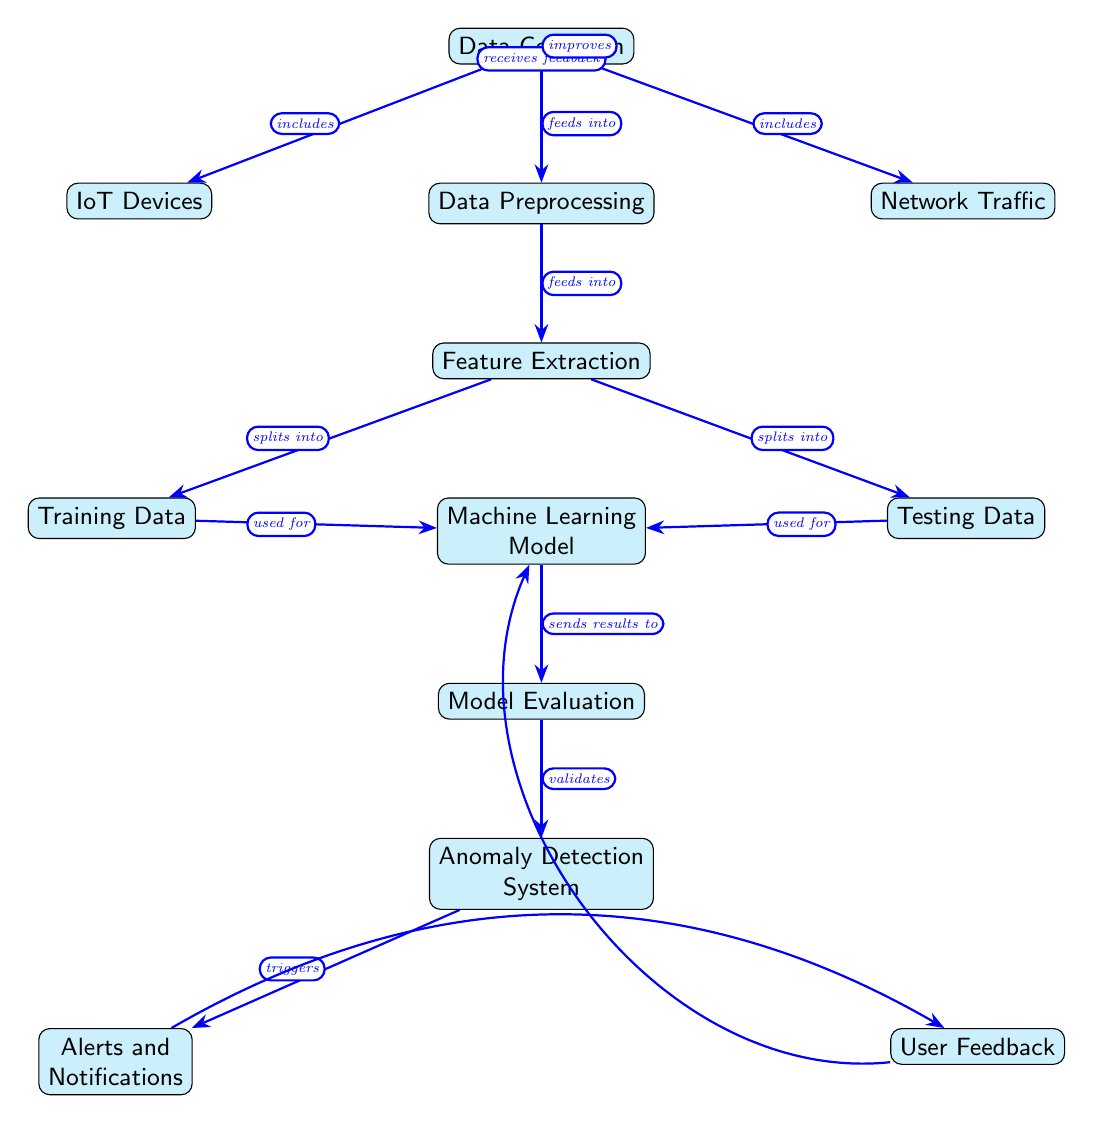What are the two types of data included in Data Collection? The diagram shows two nodes connected to Data Collection: IoT Devices and Network Traffic. These represent the types of data collected for anomaly detection.
Answer: IoT Devices, Network Traffic How many nodes are there in total? The diagram includes 12 distinct nodes, each representing a step or component in the anomaly detection process.
Answer: 12 What is the purpose of the Anomaly Detection System? Anomaly Detection System is the end goal of the process, validated by the preceding model evaluation, and it triggers alerts and notifications upon detecting anomalies.
Answer: Triggers alerts and notifications Which node follows Data Preprocessing? Data Preprocessing feeds into Feature Extraction, making it the immediate successor in the flow of the diagram.
Answer: Feature Extraction What types of data are produced from Feature Extraction? Feature Extraction splits into Training Data and Testing Data, which are both used to develop the machine learning model.
Answer: Training Data, Testing Data What does Model Evaluation send results to? The flow indicates that Model Evaluation sends results to the Anomaly Detection System, which relies on these evaluations to function effectively.
Answer: Anomaly Detection System What role does User Feedback play in the diagram? User Feedback receives input from Alerts and Notifications and is used to improve the Machine Learning Model, indicating it contributes to enhancing the system's performance over time.
Answer: Improves How many arrows are used to connect the nodes in the diagram? There are 10 arrows in the diagram, representing the connections and flow of information between the various nodes.
Answer: 10 Which nodes are directly connected to the Machine Learning Model? Training Data and Testing Data are used for the Machine Learning Model, indicating they provide the necessary input for its training and validation process.
Answer: Training Data, Testing Data 